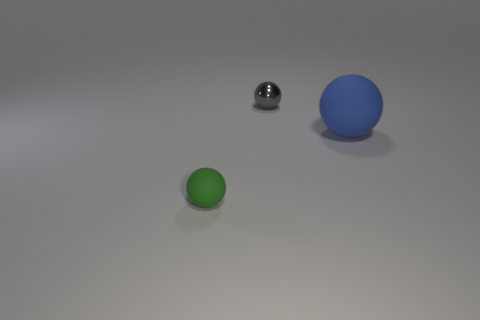Subtract all large rubber spheres. How many spheres are left? 2 Subtract all green balls. How many balls are left? 2 Add 2 tiny green spheres. How many objects exist? 5 Subtract 2 spheres. How many spheres are left? 1 Add 3 small rubber balls. How many small rubber balls exist? 4 Subtract 0 purple balls. How many objects are left? 3 Subtract all blue balls. Subtract all brown cubes. How many balls are left? 2 Subtract all yellow cylinders. How many gray spheres are left? 1 Subtract all small red matte things. Subtract all small green matte balls. How many objects are left? 2 Add 1 gray metallic things. How many gray metallic things are left? 2 